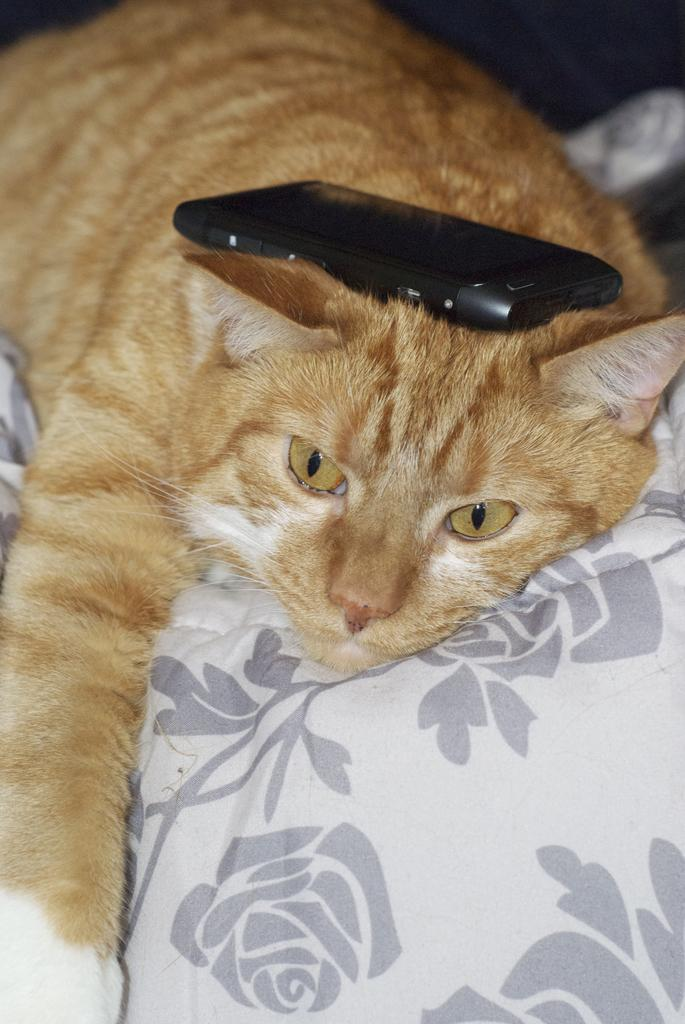What object is hanging in the image? There is a mobile in the image. What type of animal is present in the image? There is a cat in the image. Where is the cat positioned in the image? The cat is lying on a cloth. What direction is the cat facing in the image? The provided facts do not specify the direction the cat is facing in the image. 